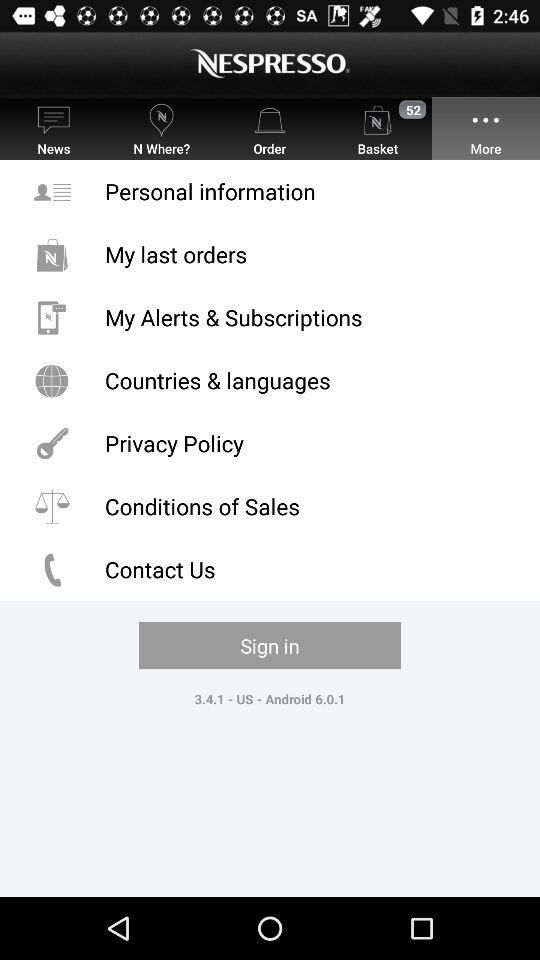What is the application name? The application name is "NESPRESSO". 